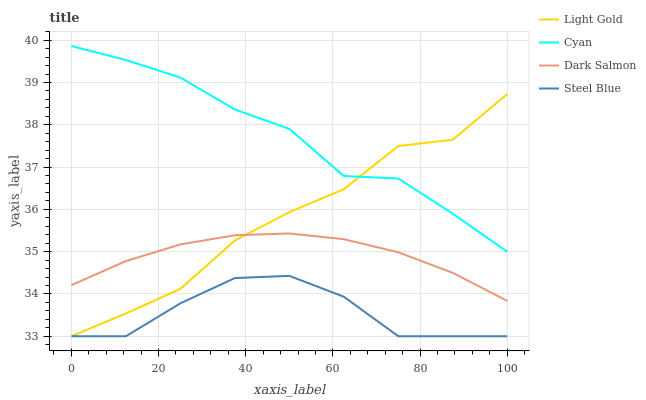Does Light Gold have the minimum area under the curve?
Answer yes or no. No. Does Light Gold have the maximum area under the curve?
Answer yes or no. No. Is Light Gold the smoothest?
Answer yes or no. No. Is Dark Salmon the roughest?
Answer yes or no. No. Does Dark Salmon have the lowest value?
Answer yes or no. No. Does Light Gold have the highest value?
Answer yes or no. No. Is Dark Salmon less than Cyan?
Answer yes or no. Yes. Is Dark Salmon greater than Steel Blue?
Answer yes or no. Yes. Does Dark Salmon intersect Cyan?
Answer yes or no. No. 